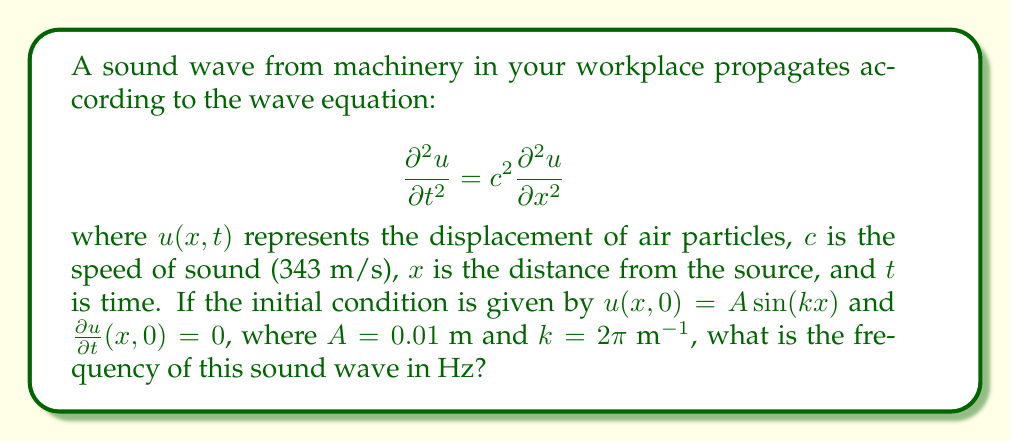Help me with this question. To solve this problem, we'll follow these steps:

1) The general solution to the wave equation with the given initial conditions is:

   $$u(x,t) = A \cos(\omega t) \sin(kx)$$

   where $\omega$ is the angular frequency.

2) We know that for a wave equation, $\omega = ck$, where $c$ is the speed of sound and $k$ is the wavenumber.

3) We're given $c = 343$ m/s and $k = 2\pi$ m⁻¹. Let's substitute these values:

   $$\omega = 343 \cdot 2\pi = 686\pi$$ rad/s

4) To convert angular frequency to frequency in Hz, we use the relation:

   $$f = \frac{\omega}{2\pi}$$

5) Substituting our value for $\omega$:

   $$f = \frac{686\pi}{2\pi} = 343$$ Hz

Therefore, the frequency of the sound wave is 343 Hz.
Answer: 343 Hz 